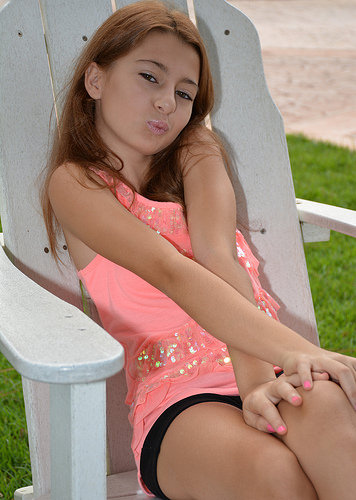<image>
Is there a girl in front of the chair? Yes. The girl is positioned in front of the chair, appearing closer to the camera viewpoint. 